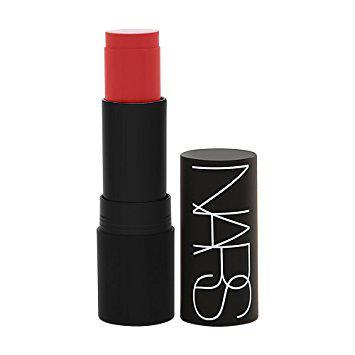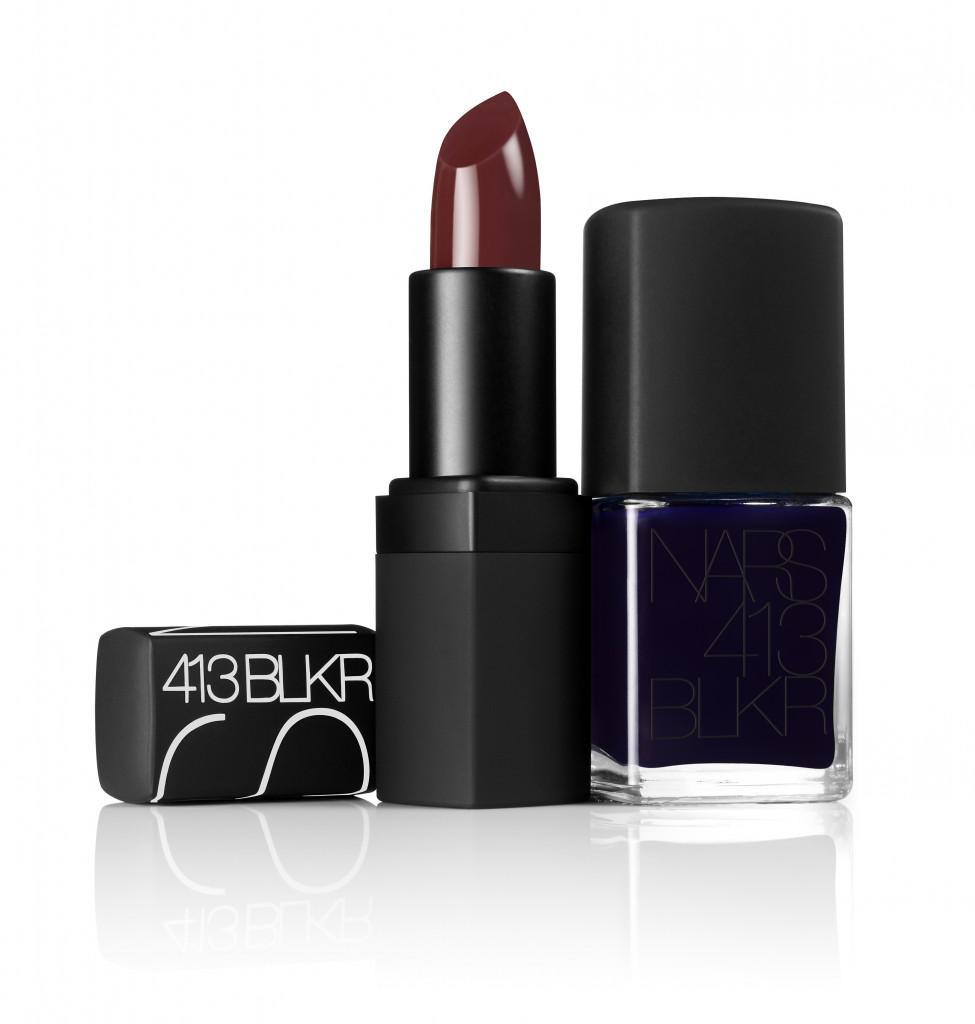The first image is the image on the left, the second image is the image on the right. Given the left and right images, does the statement "The withdrawn lipstick tube in the left image has a flat top." hold true? Answer yes or no. Yes. The first image is the image on the left, the second image is the image on the right. Analyze the images presented: Is the assertion "the left image has flat topped lipstick" valid? Answer yes or no. Yes. 